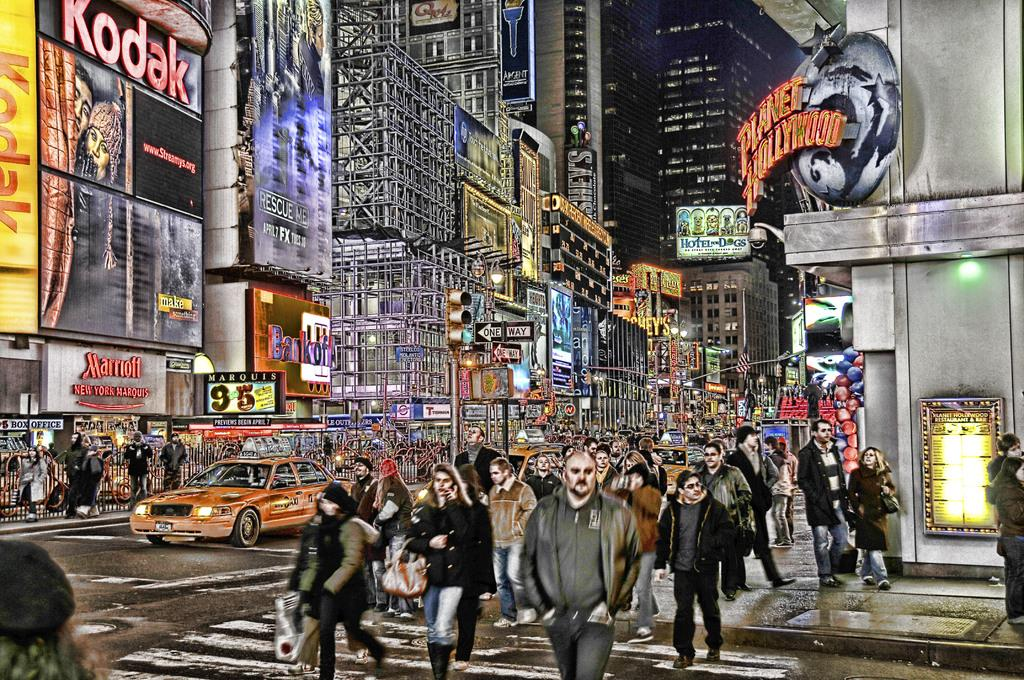What is the main subject of the image? The main subject of the image is a painting. What is being depicted in the painting? The painting depicts buildings, vehicles on the road, and people. Are there any additional features in the painting? Yes, there are boards attached to the buildings and traffic lights in the painting. What type of stone can be seen flying in the painting? There is no stone flying in the painting; it depicts buildings, vehicles, people, boards, and traffic lights. 